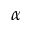Convert formula to latex. <formula><loc_0><loc_0><loc_500><loc_500>\alpha</formula> 